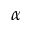Convert formula to latex. <formula><loc_0><loc_0><loc_500><loc_500>\alpha</formula> 